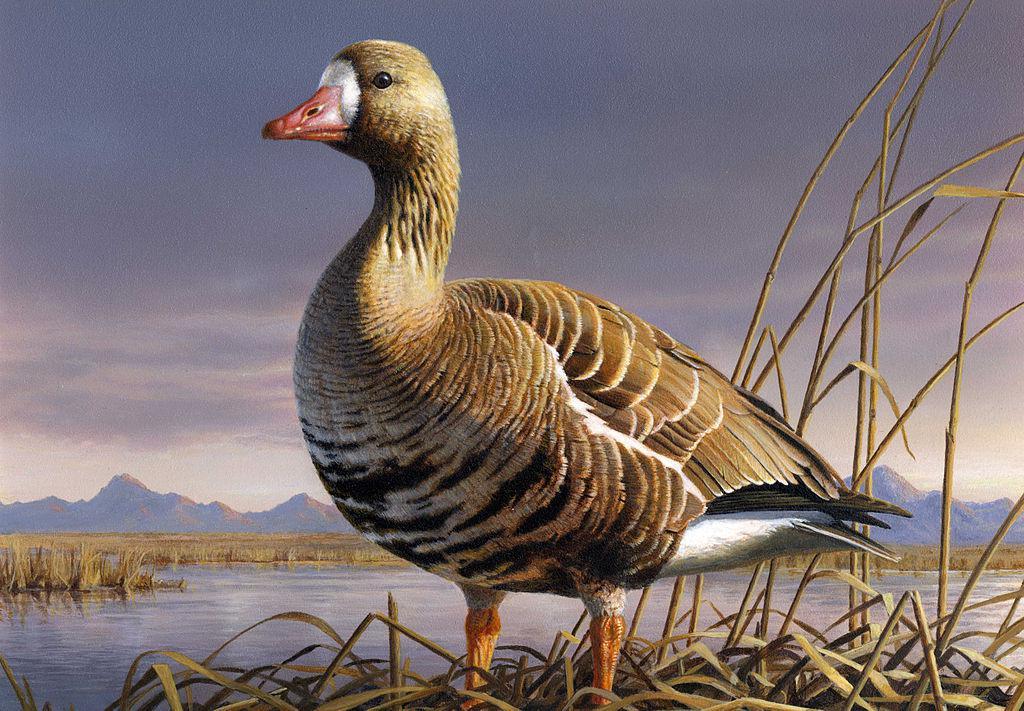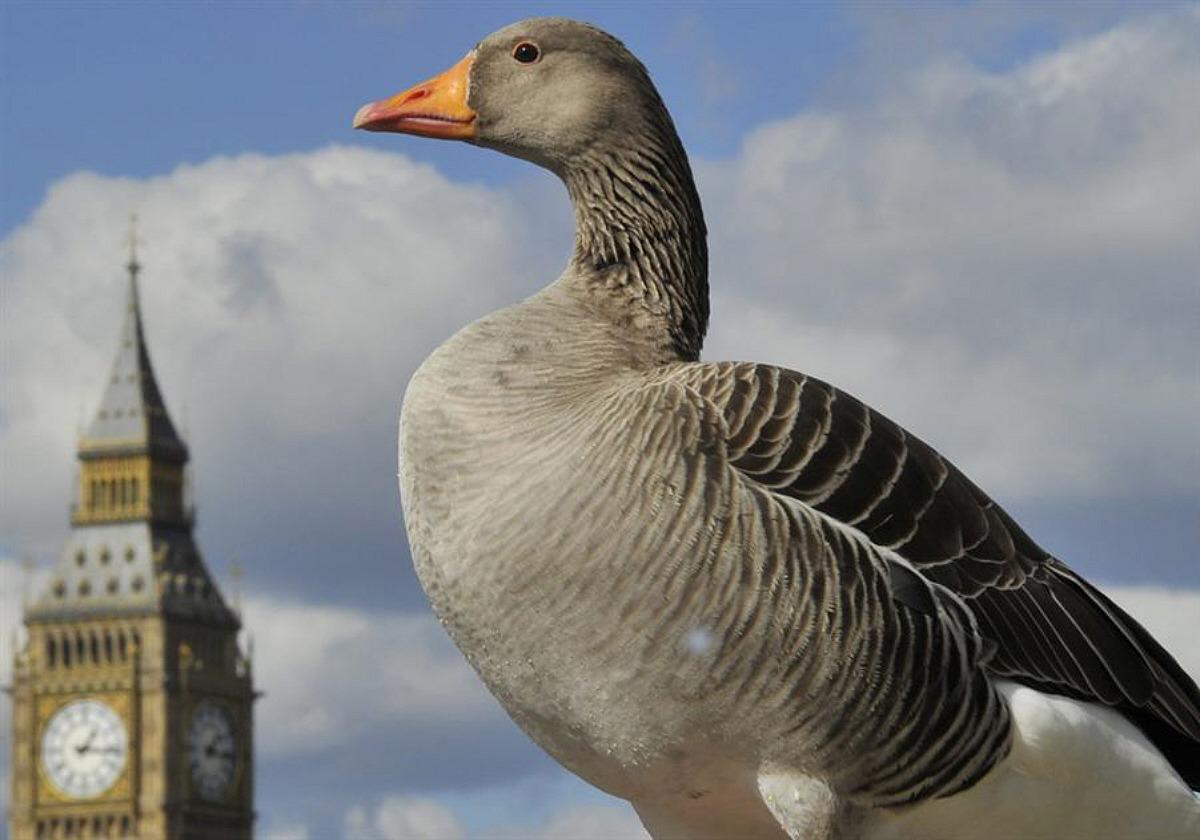The first image is the image on the left, the second image is the image on the right. Examine the images to the left and right. Is the description "There are more than two birds total." accurate? Answer yes or no. No. 